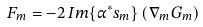Convert formula to latex. <formula><loc_0><loc_0><loc_500><loc_500>F _ { m } = - 2 \, I m \{ \alpha ^ { * } s _ { m } \} \left ( \nabla _ { m } G _ { m } \right )</formula> 